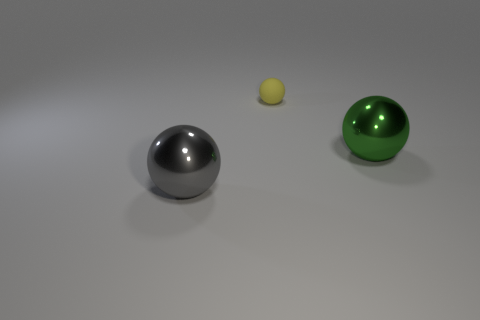Add 3 cyan objects. How many objects exist? 6 Subtract all tiny brown rubber things. Subtract all green metal balls. How many objects are left? 2 Add 1 large shiny spheres. How many large shiny spheres are left? 3 Add 2 small matte spheres. How many small matte spheres exist? 3 Subtract 0 green cylinders. How many objects are left? 3 